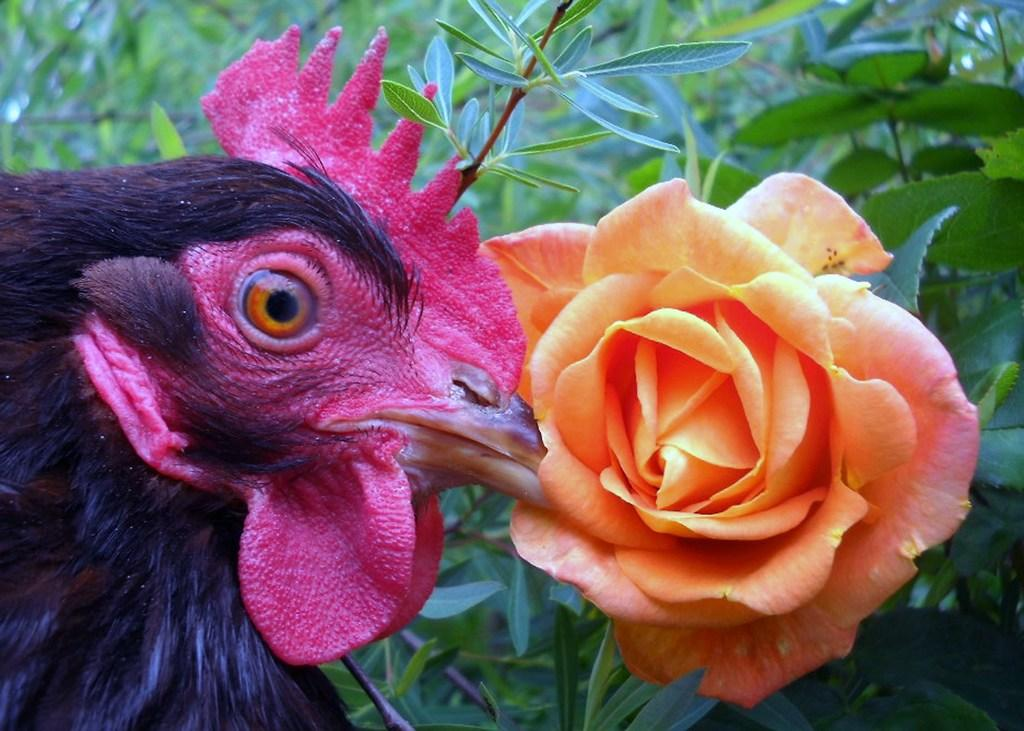What animal is in the image? There is a cock in the image. On which side of the image is the cock located? The cock is on the left side of the image. What is in front of the cock? There is a rose in front of the cock. What can be seen behind the cock and the rose? There are stems with leaves behind the cock and the rose. What type of soap is being used to clean the alley in the image? There is no soap or alley present in the image; it features a cock, a rose, and stems with leaves. 